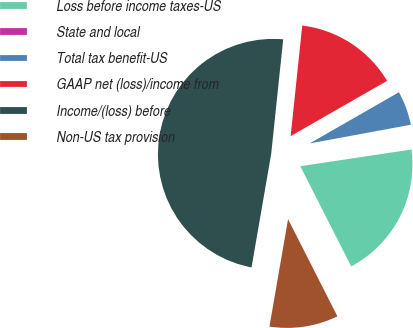Convert chart. <chart><loc_0><loc_0><loc_500><loc_500><pie_chart><fcel>Loss before income taxes-US<fcel>State and local<fcel>Total tax benefit-US<fcel>GAAP net (loss)/income from<fcel>Income/(loss) before<fcel>Non-US tax provision<nl><fcel>19.89%<fcel>0.54%<fcel>5.37%<fcel>15.05%<fcel>48.93%<fcel>10.21%<nl></chart> 